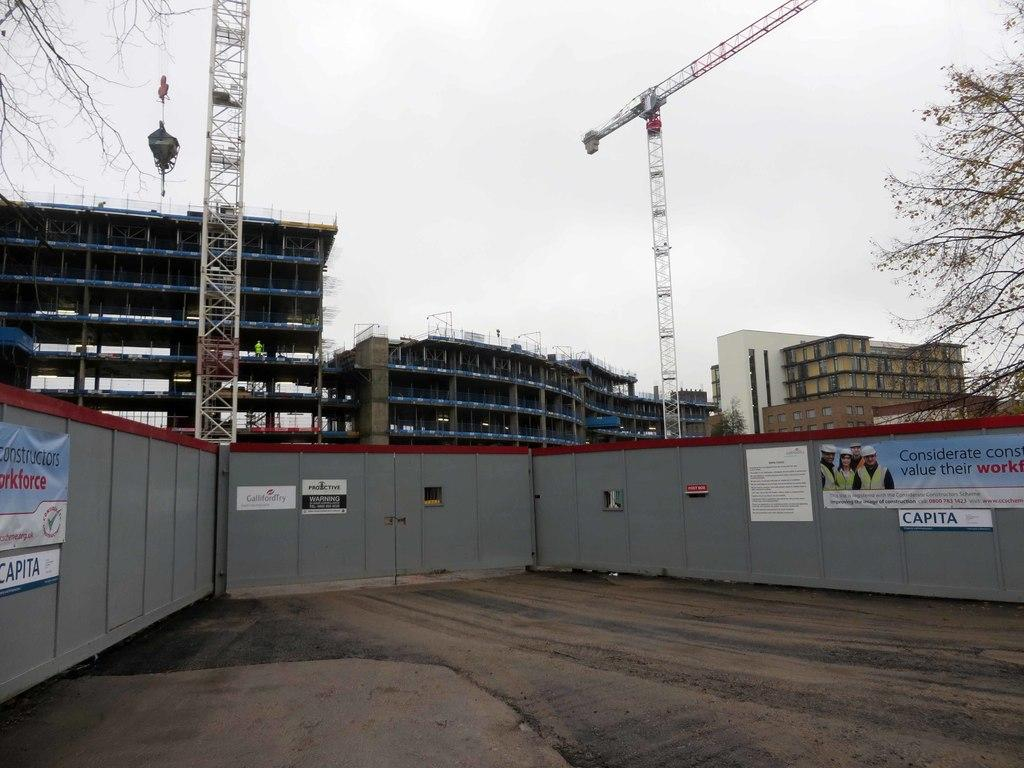What can be seen in the background of the image? There are buildings and cranes in the background of the image. What type of vegetation is on the left side of the image? There are trees on the left side of the image. What type of vegetation is on the right side of the image? There are trees on the right side of the image. What is located in the middle of the image? There is a wall in the middle of the image. Can you tell me how many flowers are growing on the wall in the image? There are no flowers present on the wall in the image. What type of clover can be seen on the left side of the image? There is no clover present in the image; it features trees on the left side. 